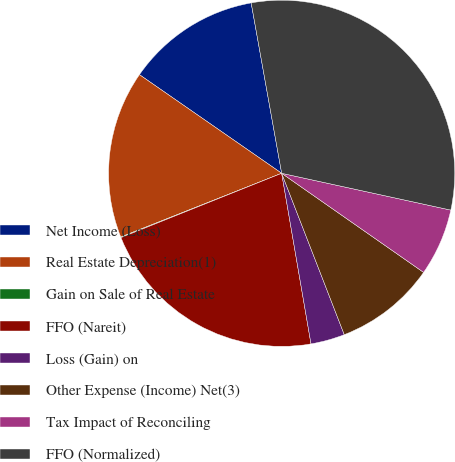Convert chart. <chart><loc_0><loc_0><loc_500><loc_500><pie_chart><fcel>Net Income (Loss)<fcel>Real Estate Depreciation(1)<fcel>Gain on Sale of Real Estate<fcel>FFO (Nareit)<fcel>Loss (Gain) on<fcel>Other Expense (Income) Net(3)<fcel>Tax Impact of Reconciling<fcel>FFO (Normalized)<nl><fcel>12.53%<fcel>15.65%<fcel>0.06%<fcel>21.65%<fcel>3.18%<fcel>9.41%<fcel>6.29%<fcel>31.23%<nl></chart> 